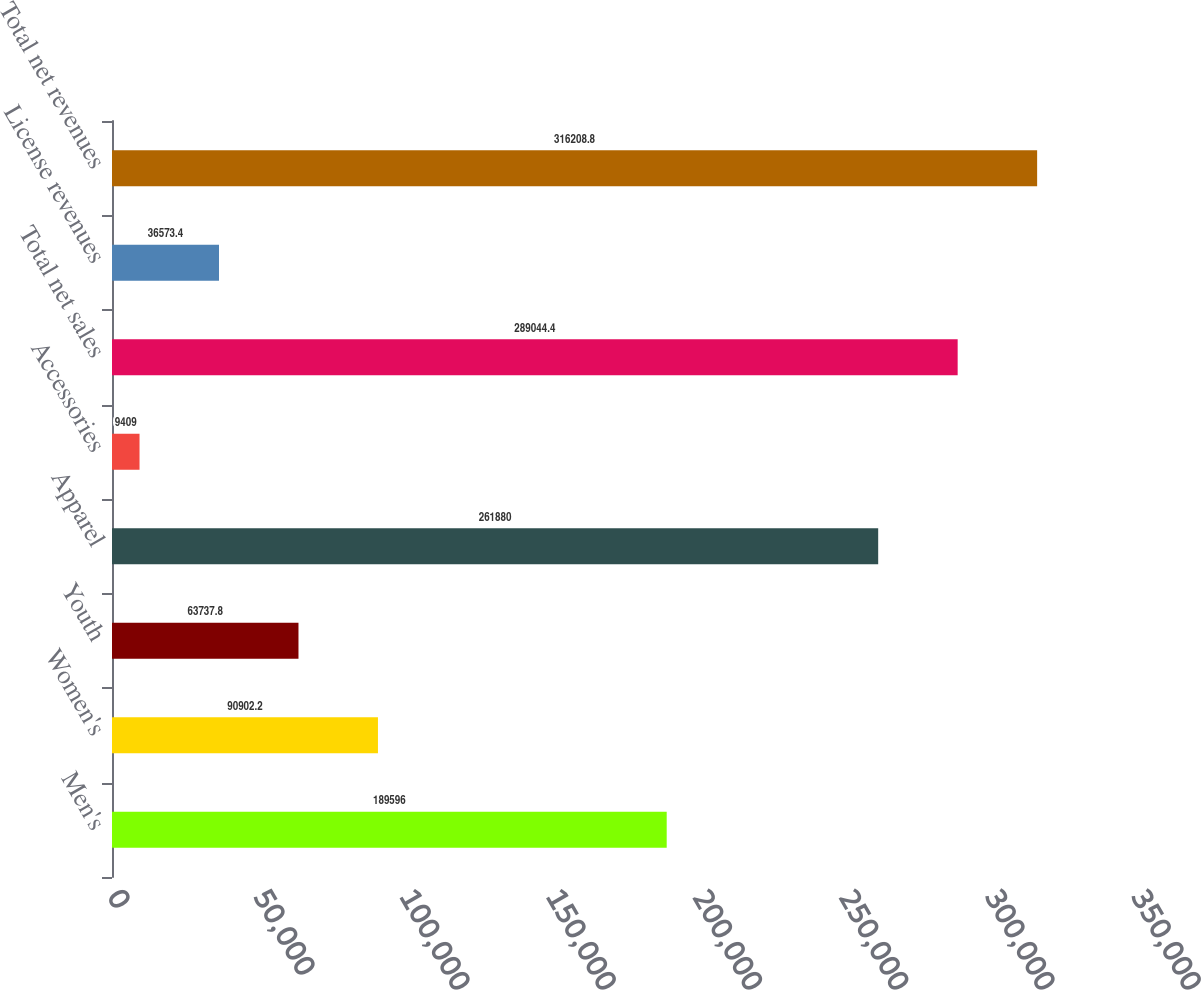Convert chart. <chart><loc_0><loc_0><loc_500><loc_500><bar_chart><fcel>Men's<fcel>Women's<fcel>Youth<fcel>Apparel<fcel>Accessories<fcel>Total net sales<fcel>License revenues<fcel>Total net revenues<nl><fcel>189596<fcel>90902.2<fcel>63737.8<fcel>261880<fcel>9409<fcel>289044<fcel>36573.4<fcel>316209<nl></chart> 